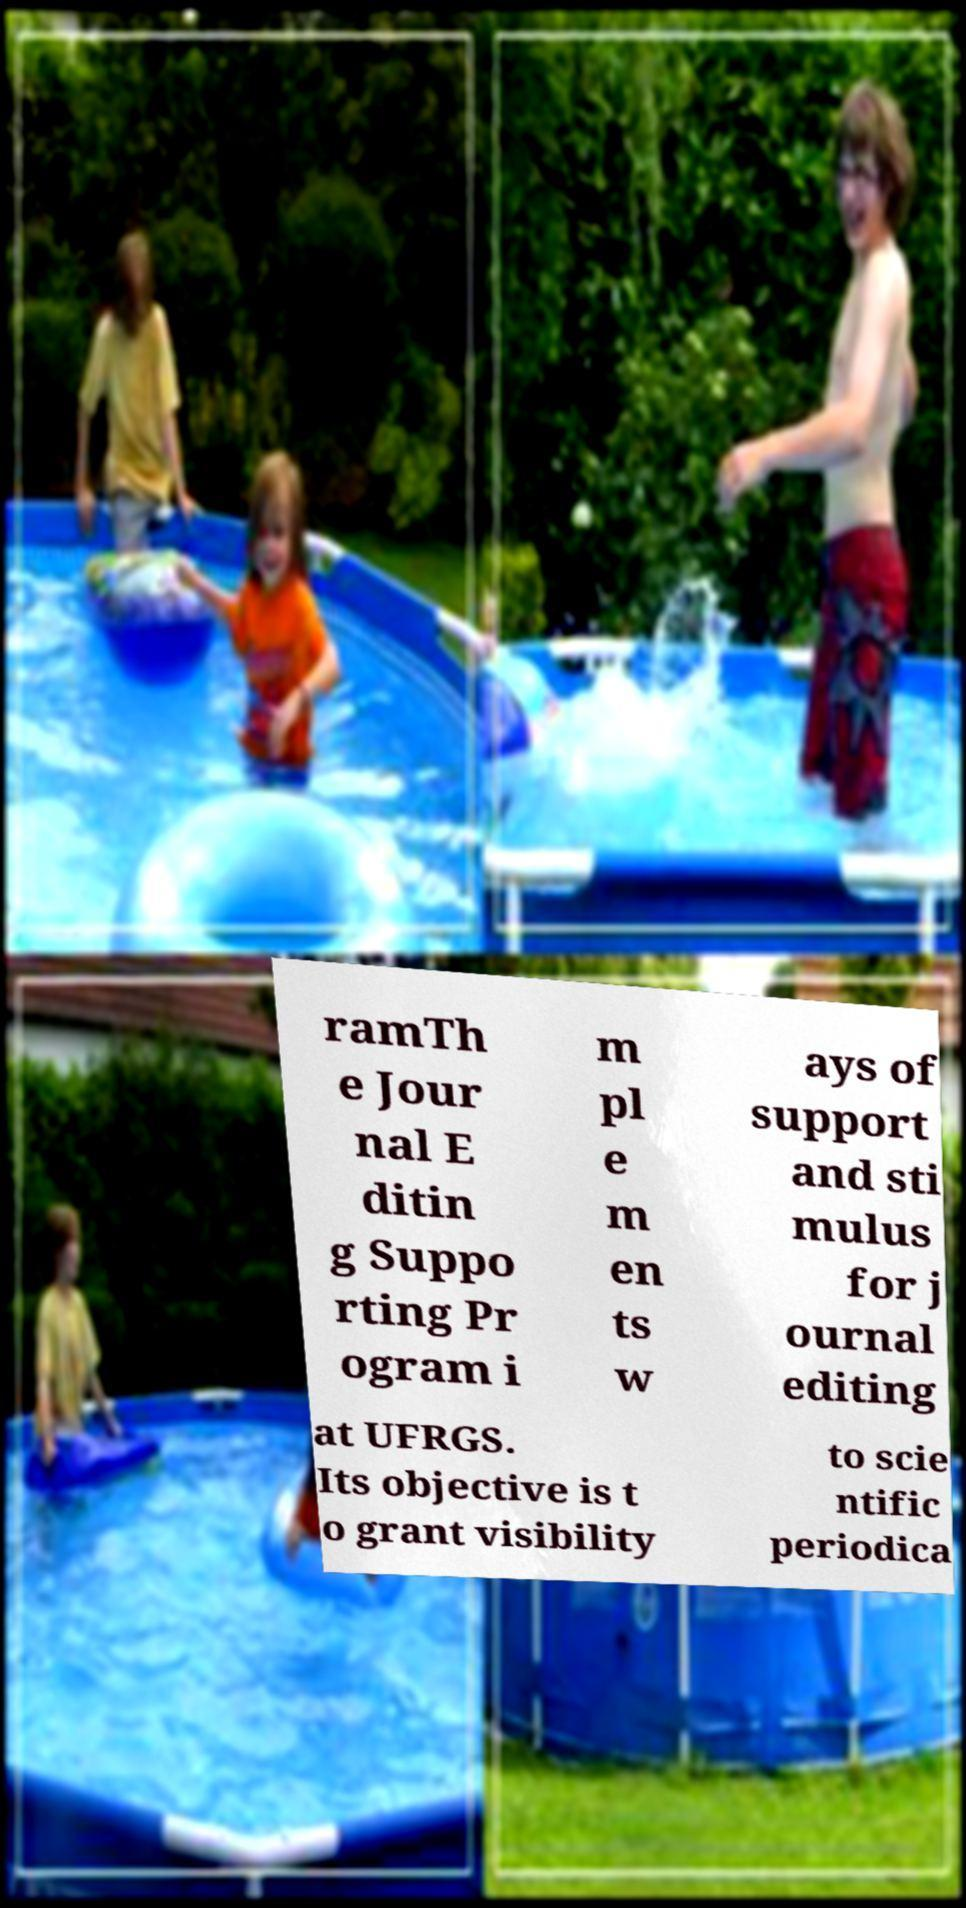Can you accurately transcribe the text from the provided image for me? ramTh e Jour nal E ditin g Suppo rting Pr ogram i m pl e m en ts w ays of support and sti mulus for j ournal editing at UFRGS. Its objective is t o grant visibility to scie ntific periodica 